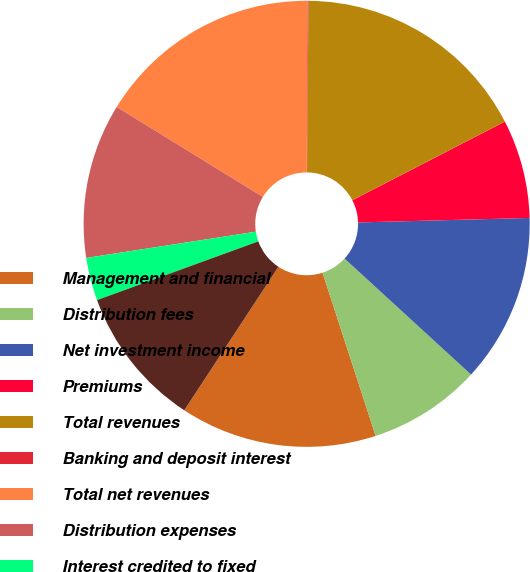Convert chart. <chart><loc_0><loc_0><loc_500><loc_500><pie_chart><fcel>Management and financial<fcel>Distribution fees<fcel>Net investment income<fcel>Premiums<fcel>Total revenues<fcel>Banking and deposit interest<fcel>Total net revenues<fcel>Distribution expenses<fcel>Interest credited to fixed<fcel>Benefits claims losses and<nl><fcel>14.25%<fcel>8.18%<fcel>12.23%<fcel>7.16%<fcel>17.29%<fcel>0.07%<fcel>16.28%<fcel>11.22%<fcel>3.11%<fcel>10.2%<nl></chart> 